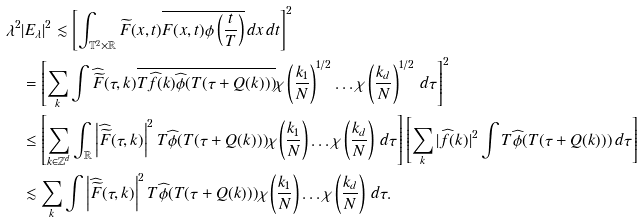<formula> <loc_0><loc_0><loc_500><loc_500>\lambda ^ { 2 } & | E _ { \lambda } | ^ { 2 } \lesssim \left [ \int _ { \mathbb { T } ^ { 2 } \times \mathbb { R } } \widetilde { F } ( x , t ) \overline { F ( x , t ) \phi \left ( \frac { t } { T } \right ) } \, d x \, d t \right ] ^ { 2 } \\ & = \left [ \sum _ { k } \int \widehat { \widetilde { F } } ( \tau , k ) \overline { T \widehat { f } ( k ) \widehat { \phi } ( T ( \tau + Q ( k ) ) ) } \chi \left ( \frac { k _ { 1 } } { N } \right ) ^ { 1 / 2 } \dots \chi \left ( \frac { k _ { d } } { N } \right ) ^ { 1 / 2 } \, d \tau \right ] ^ { 2 } \\ & \leq \left [ \sum _ { k \in \mathbb { Z } ^ { d } } \int _ { \mathbb { R } } \left | \widehat { \widetilde { F } } ( \tau , k ) \right | ^ { 2 } T \widehat { \phi } ( T ( \tau + Q ( k ) ) ) \chi \left ( \frac { k _ { 1 } } { N } \right ) \dots \chi \left ( \frac { k _ { d } } { N } \right ) \, d \tau \right ] \left [ \sum _ { k } | \widehat { f } ( k ) | ^ { 2 } \int T \widehat { \phi } ( T ( \tau + Q ( k ) ) ) \, d \tau \right ] \\ & \lesssim \sum _ { k } \int \left | \widehat { \widetilde { F } } ( \tau , k ) \right | ^ { 2 } T \widehat { \phi } ( T ( \tau + Q ( k ) ) ) \chi \left ( \frac { k _ { 1 } } { N } \right ) \dots \chi \left ( \frac { k _ { d } } { N } \right ) \, d \tau .</formula> 